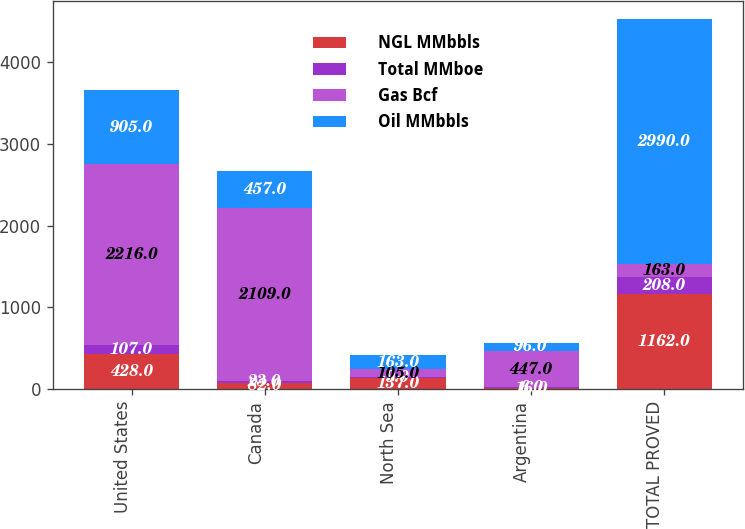<chart> <loc_0><loc_0><loc_500><loc_500><stacked_bar_chart><ecel><fcel>United States<fcel>Canada<fcel>North Sea<fcel>Argentina<fcel>TOTAL PROVED<nl><fcel>NGL MMbbls<fcel>428<fcel>82<fcel>137<fcel>16<fcel>1162<nl><fcel>Total MMboe<fcel>107<fcel>23<fcel>9<fcel>6<fcel>208<nl><fcel>Gas Bcf<fcel>2216<fcel>2109<fcel>105<fcel>447<fcel>163<nl><fcel>Oil MMbbls<fcel>905<fcel>457<fcel>163<fcel>96<fcel>2990<nl></chart> 